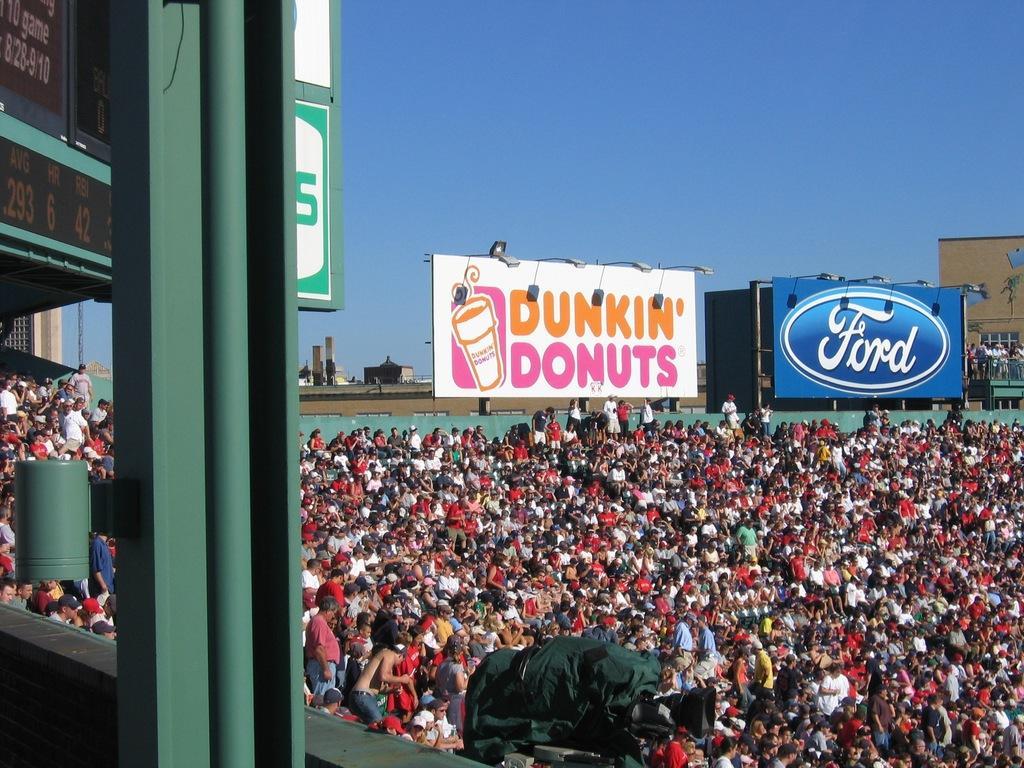Describe this image in one or two sentences. In the picture we can see a public standing and sitting, just beside them, we can see a green color pillar and in the background, we can see a wall which is also green in color and to it we can see a boards Dunkin donuts, and ford symbol and in the background also we can see some buildings and a sky. 